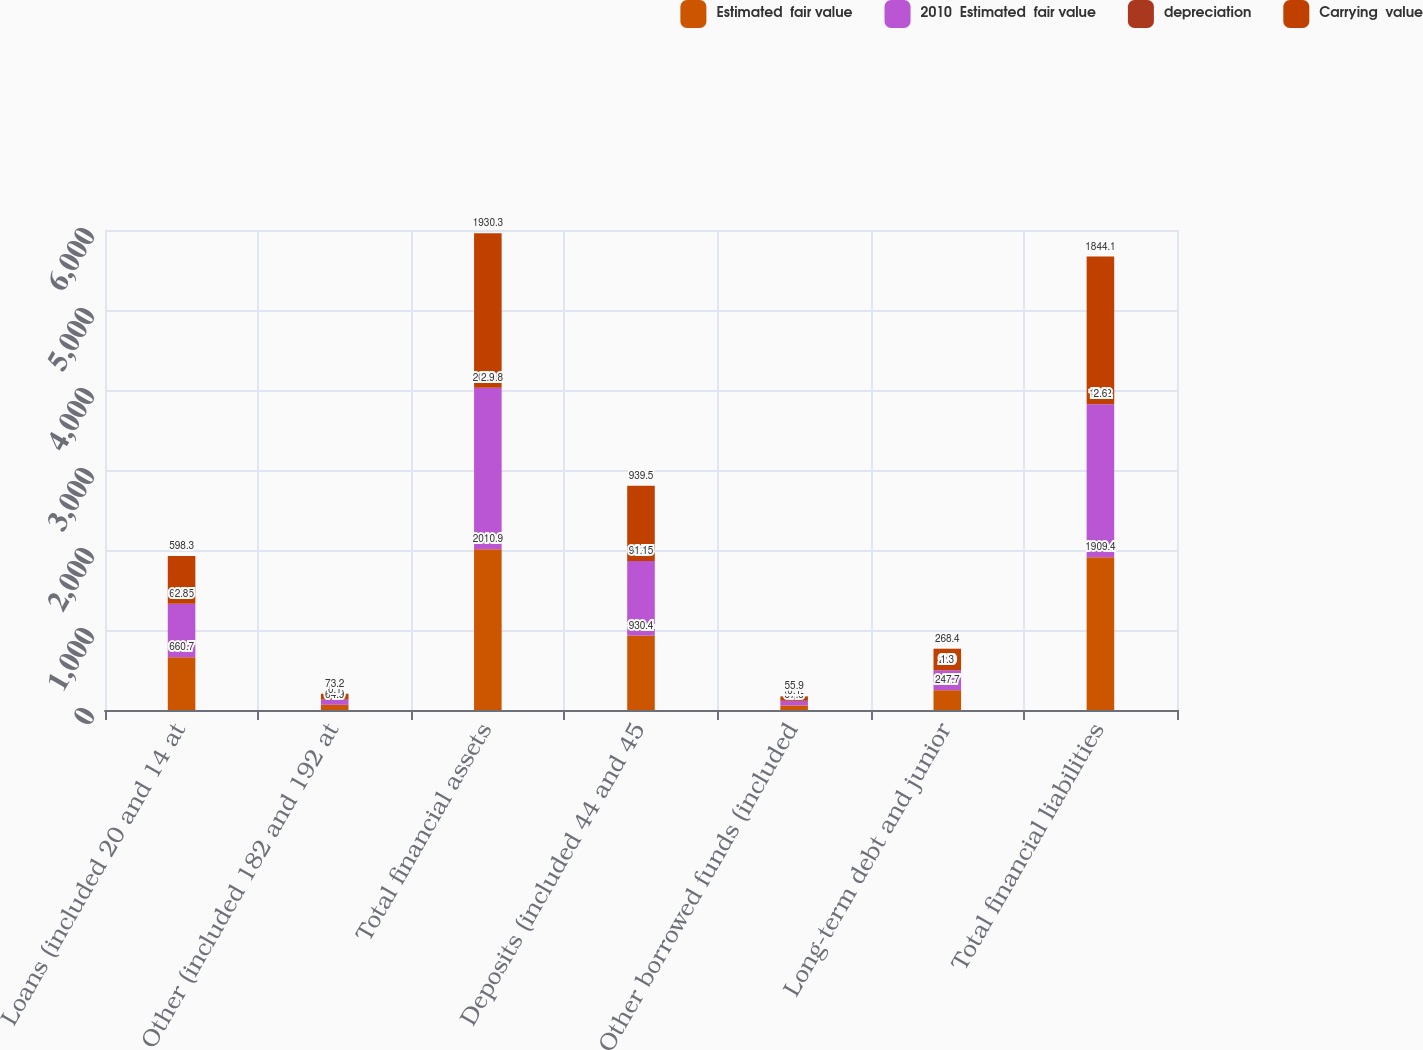<chart> <loc_0><loc_0><loc_500><loc_500><stacked_bar_chart><ecel><fcel>Loans (included 20 and 14 at<fcel>Other (included 182 and 192 at<fcel>Total financial assets<fcel>Deposits (included 44 and 45<fcel>Other borrowed funds (included<fcel>Long-term debt and junior<fcel>Total financial liabilities<nl><fcel>Estimated  fair value<fcel>660.7<fcel>64.9<fcel>2010.9<fcel>930.4<fcel>57.3<fcel>247.7<fcel>1909.4<nl><fcel>2010  Estimated  fair value<fcel>663.5<fcel>65<fcel>2013.8<fcel>931.5<fcel>57.2<fcel>249<fcel>1912<nl><fcel>depreciation<fcel>2.8<fcel>0.1<fcel>2.9<fcel>1.1<fcel>0.1<fcel>1.3<fcel>2.6<nl><fcel>Carrying  value<fcel>598.3<fcel>73.2<fcel>1930.3<fcel>939.5<fcel>55.9<fcel>268.4<fcel>1844.1<nl></chart> 